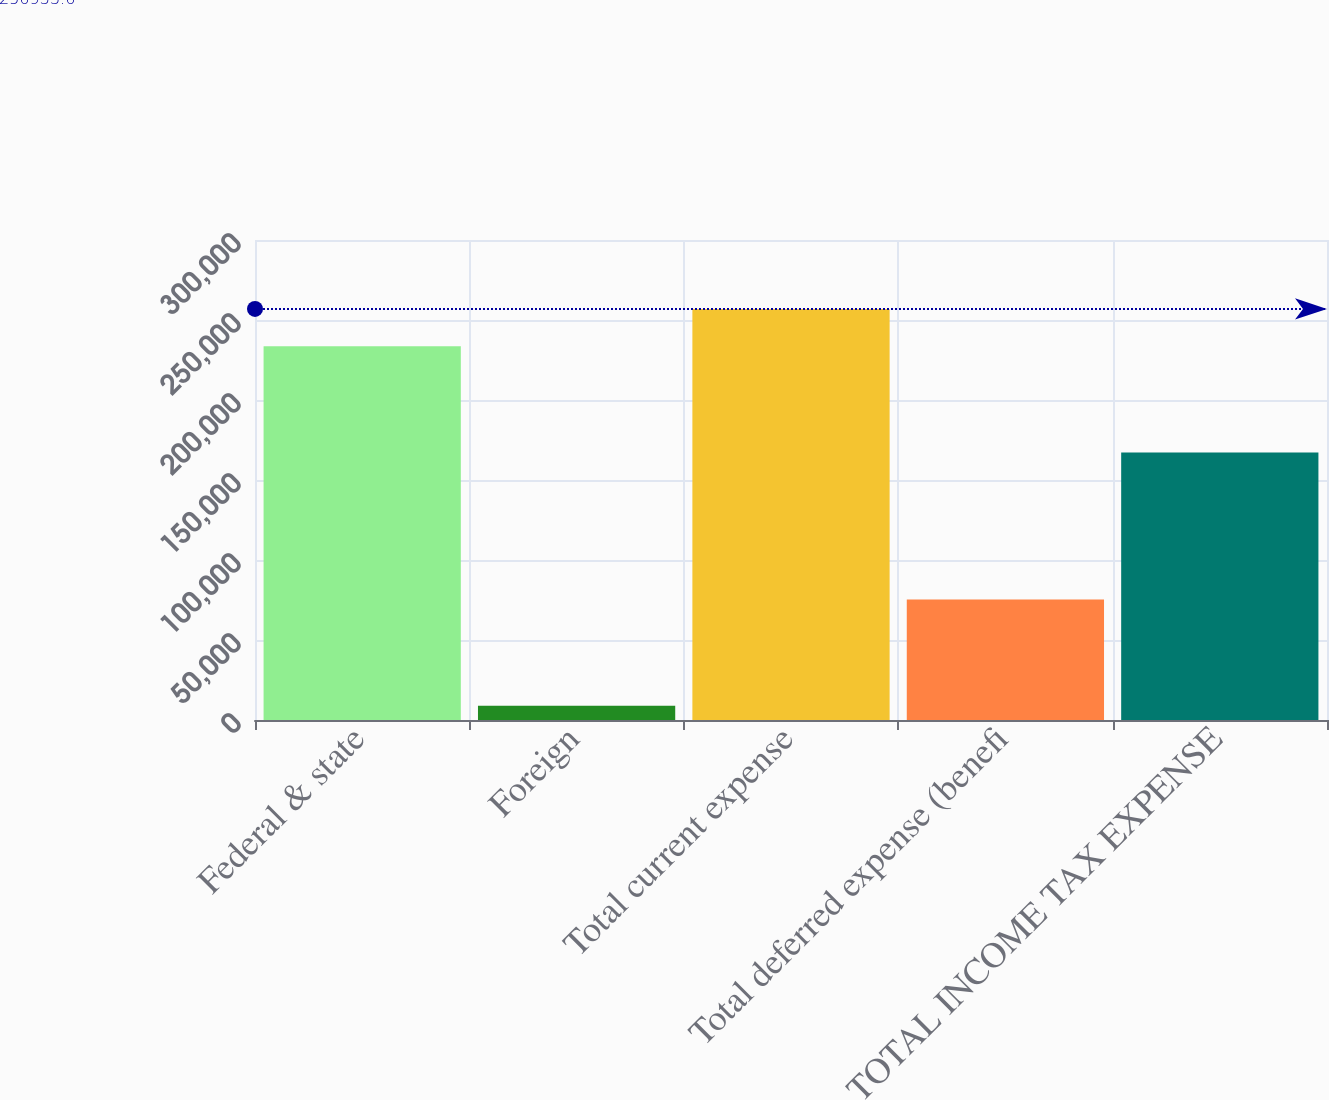Convert chart to OTSL. <chart><loc_0><loc_0><loc_500><loc_500><bar_chart><fcel>Federal & state<fcel>Foreign<fcel>Total current expense<fcel>Total deferred expense (benefi<fcel>TOTAL INCOME TAX EXPENSE<nl><fcel>233576<fcel>8970<fcel>256934<fcel>75375<fcel>167171<nl></chart> 